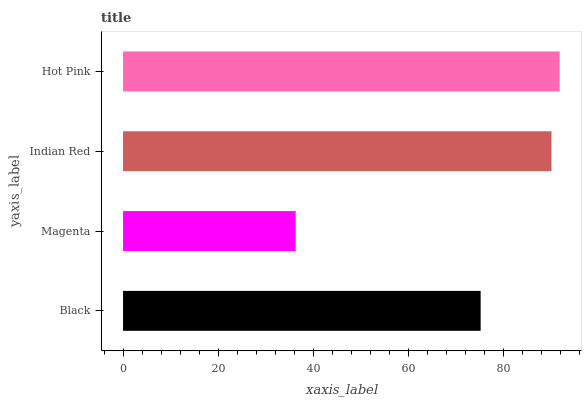Is Magenta the minimum?
Answer yes or no. Yes. Is Hot Pink the maximum?
Answer yes or no. Yes. Is Indian Red the minimum?
Answer yes or no. No. Is Indian Red the maximum?
Answer yes or no. No. Is Indian Red greater than Magenta?
Answer yes or no. Yes. Is Magenta less than Indian Red?
Answer yes or no. Yes. Is Magenta greater than Indian Red?
Answer yes or no. No. Is Indian Red less than Magenta?
Answer yes or no. No. Is Indian Red the high median?
Answer yes or no. Yes. Is Black the low median?
Answer yes or no. Yes. Is Magenta the high median?
Answer yes or no. No. Is Magenta the low median?
Answer yes or no. No. 